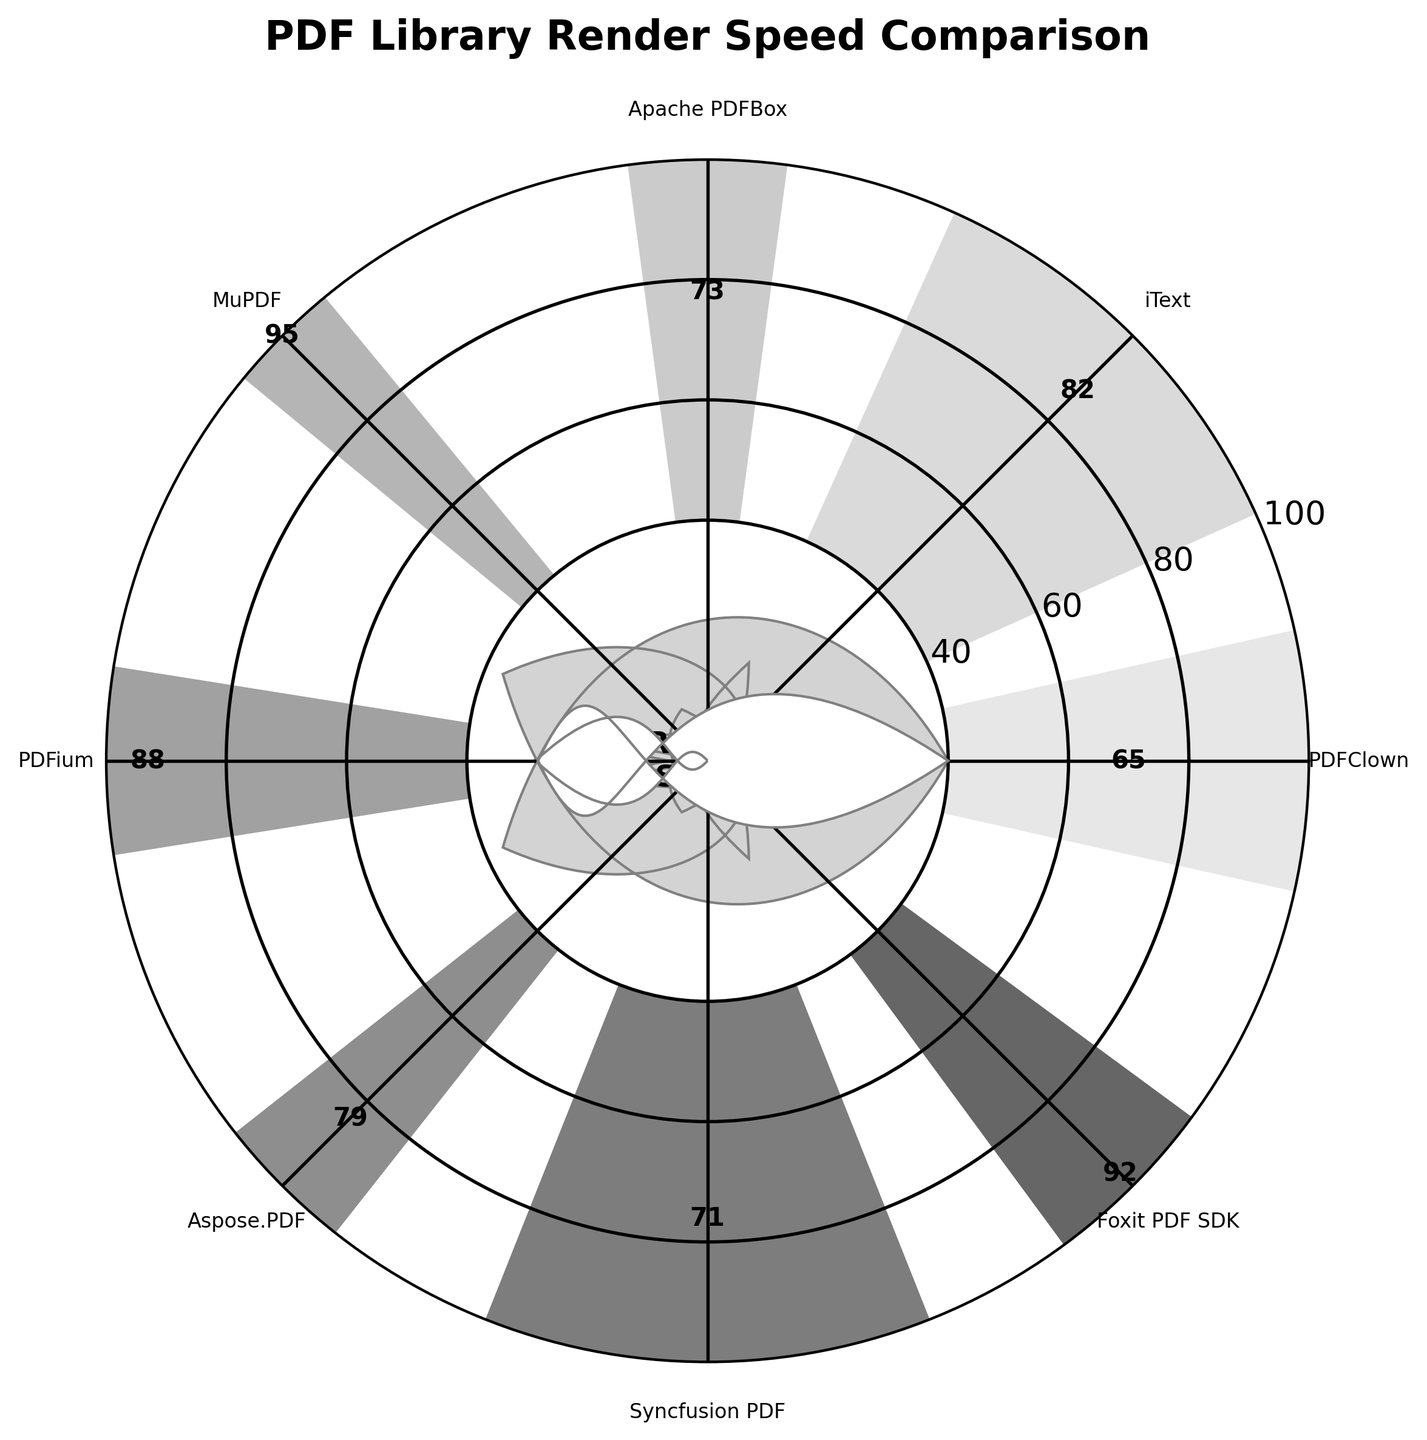What's the title of the figure? The title is always located at the top of the figure. By observing this position, we can see that the title reads "PDF Library Render Speed Comparison".
Answer: PDF Library Render Speed Comparison How many PDF libraries are compared in the figure? By counting the labels on the x-axis, which represent different PDF libraries, we can determine that there are 8 libraries.
Answer: 8 Which PDF library has the highest render speed? To find the highest render speed, look for the bar that extends the farthest from the center of the polar chart. Here, MuPDF's bar extends the farthest, indicating it has the highest speed.
Answer: MuPDF What is the render speed of PDFClown? Locate the label for PDFClown and read the numerical value displayed on its corresponding bar. The value is shown as '65'.
Answer: 65 Which PDF library has a render speed closest to 80? To determine the library with a render speed closest to 80, compare the speeds of all the libraries. Here, iText has a speed of 82, which is the nearest to 80.
Answer: iText What is the difference in render speed between Foxit PDF SDK and PDFClown? To find the difference, subtract the render speed of PDFClown (65) from that of Foxit PDF SDK (92). 92 - 65 = 27.
Answer: 27 Which libraries have a render speed below 75? To answer, identify all the libraries with render speeds less than 75. These are PDFClown (65), Apache PDFBox (73), and Syncfusion PDF (71).
Answer: PDFClown, Apache PDFBox, Syncfusion PDF What is the average render speed of all the libraries? To find the average, sum up all the render speeds and divide by the number of libraries. The sum is 65 + 82 + 73 + 95 + 88 + 79 + 71 + 92 = 645. Dividing by 8 libraries gives an average of 645/8 = 80.625.
Answer: 80.625 Which library has a speed larger than 80 but smaller than 90? Identify libraries fitting the criteria. PDFium has a render speed of 88, while iText has a speed of 82. Both satisfy the condition of being between 80 and 90.
Answer: PDFium, iText Is the center circle area indicating any specific value or message? The figure shows a circle in the center, inside of which is written 'Render Speed'. This indicates the measurement represented by the surrounding bars.
Answer: Render Speed 